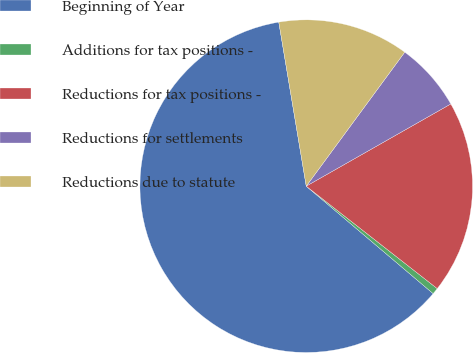Convert chart. <chart><loc_0><loc_0><loc_500><loc_500><pie_chart><fcel>Beginning of Year<fcel>Additions for tax positions -<fcel>Reductions for tax positions -<fcel>Reductions for settlements<fcel>Reductions due to statute<nl><fcel>61.17%<fcel>0.62%<fcel>18.79%<fcel>6.68%<fcel>12.73%<nl></chart> 